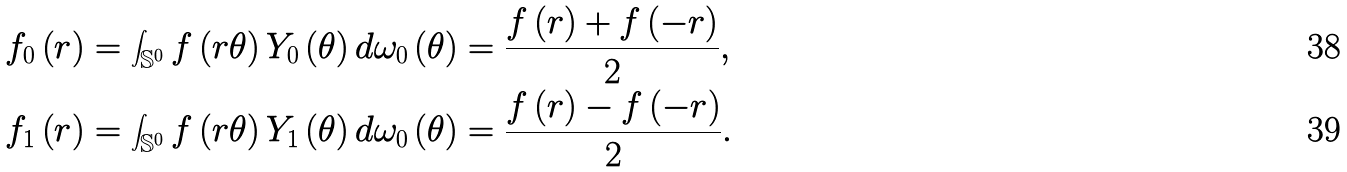<formula> <loc_0><loc_0><loc_500><loc_500>f _ { 0 } \left ( r \right ) & = \int _ { \mathbb { S } ^ { 0 } } f \left ( r \theta \right ) Y _ { 0 } \left ( \theta \right ) d \omega _ { 0 } \left ( \theta \right ) = \frac { f \left ( r \right ) + f \left ( - r \right ) } { 2 } , \\ f _ { 1 } \left ( r \right ) & = \int _ { \mathbb { S } ^ { 0 } } f \left ( r \theta \right ) Y _ { 1 } \left ( \theta \right ) d \omega _ { 0 } \left ( \theta \right ) = \frac { f \left ( r \right ) - f \left ( - r \right ) } { 2 } .</formula> 